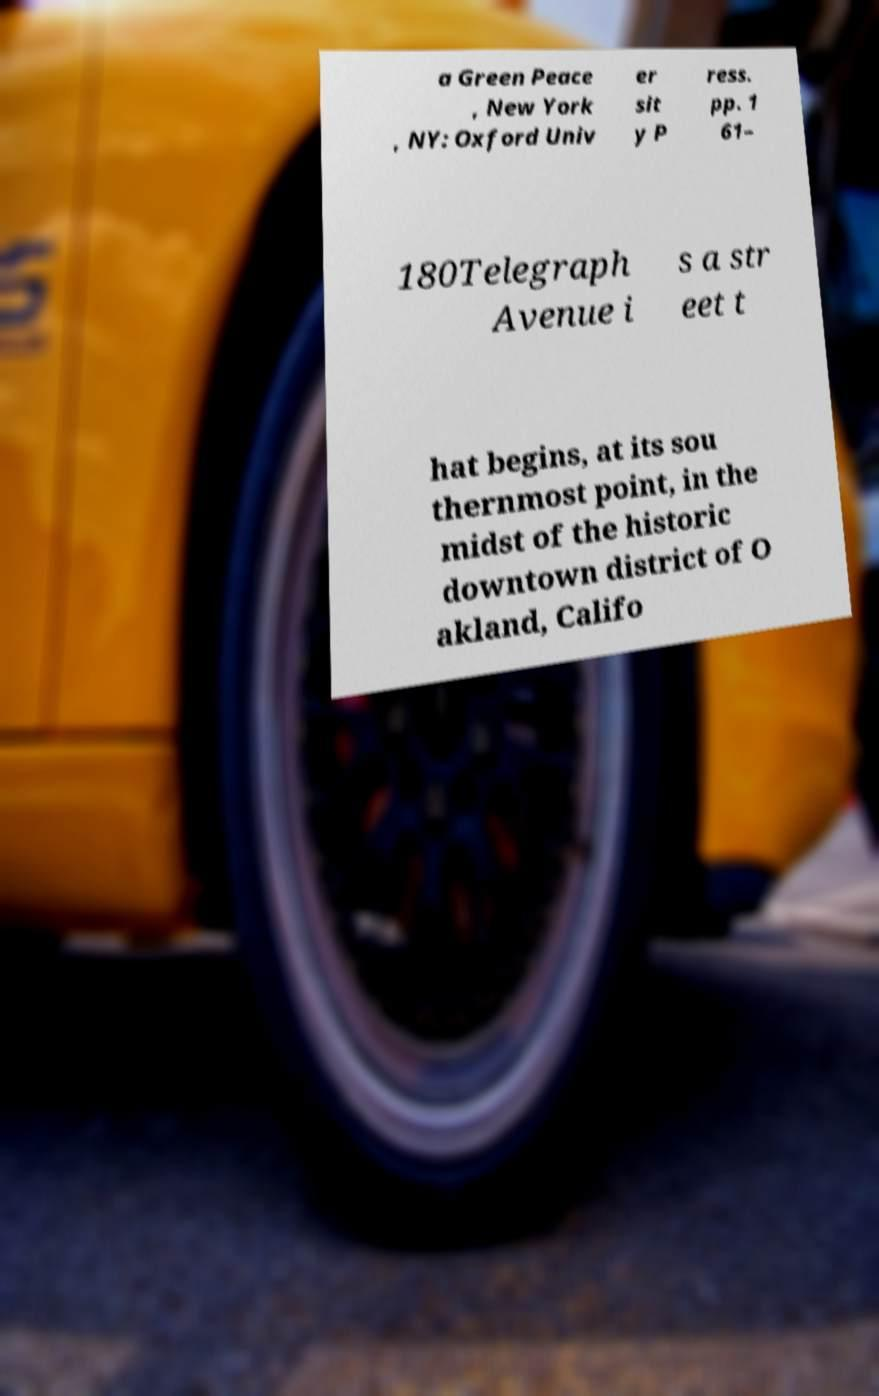Could you extract and type out the text from this image? a Green Peace , New York , NY: Oxford Univ er sit y P ress. pp. 1 61– 180Telegraph Avenue i s a str eet t hat begins, at its sou thernmost point, in the midst of the historic downtown district of O akland, Califo 